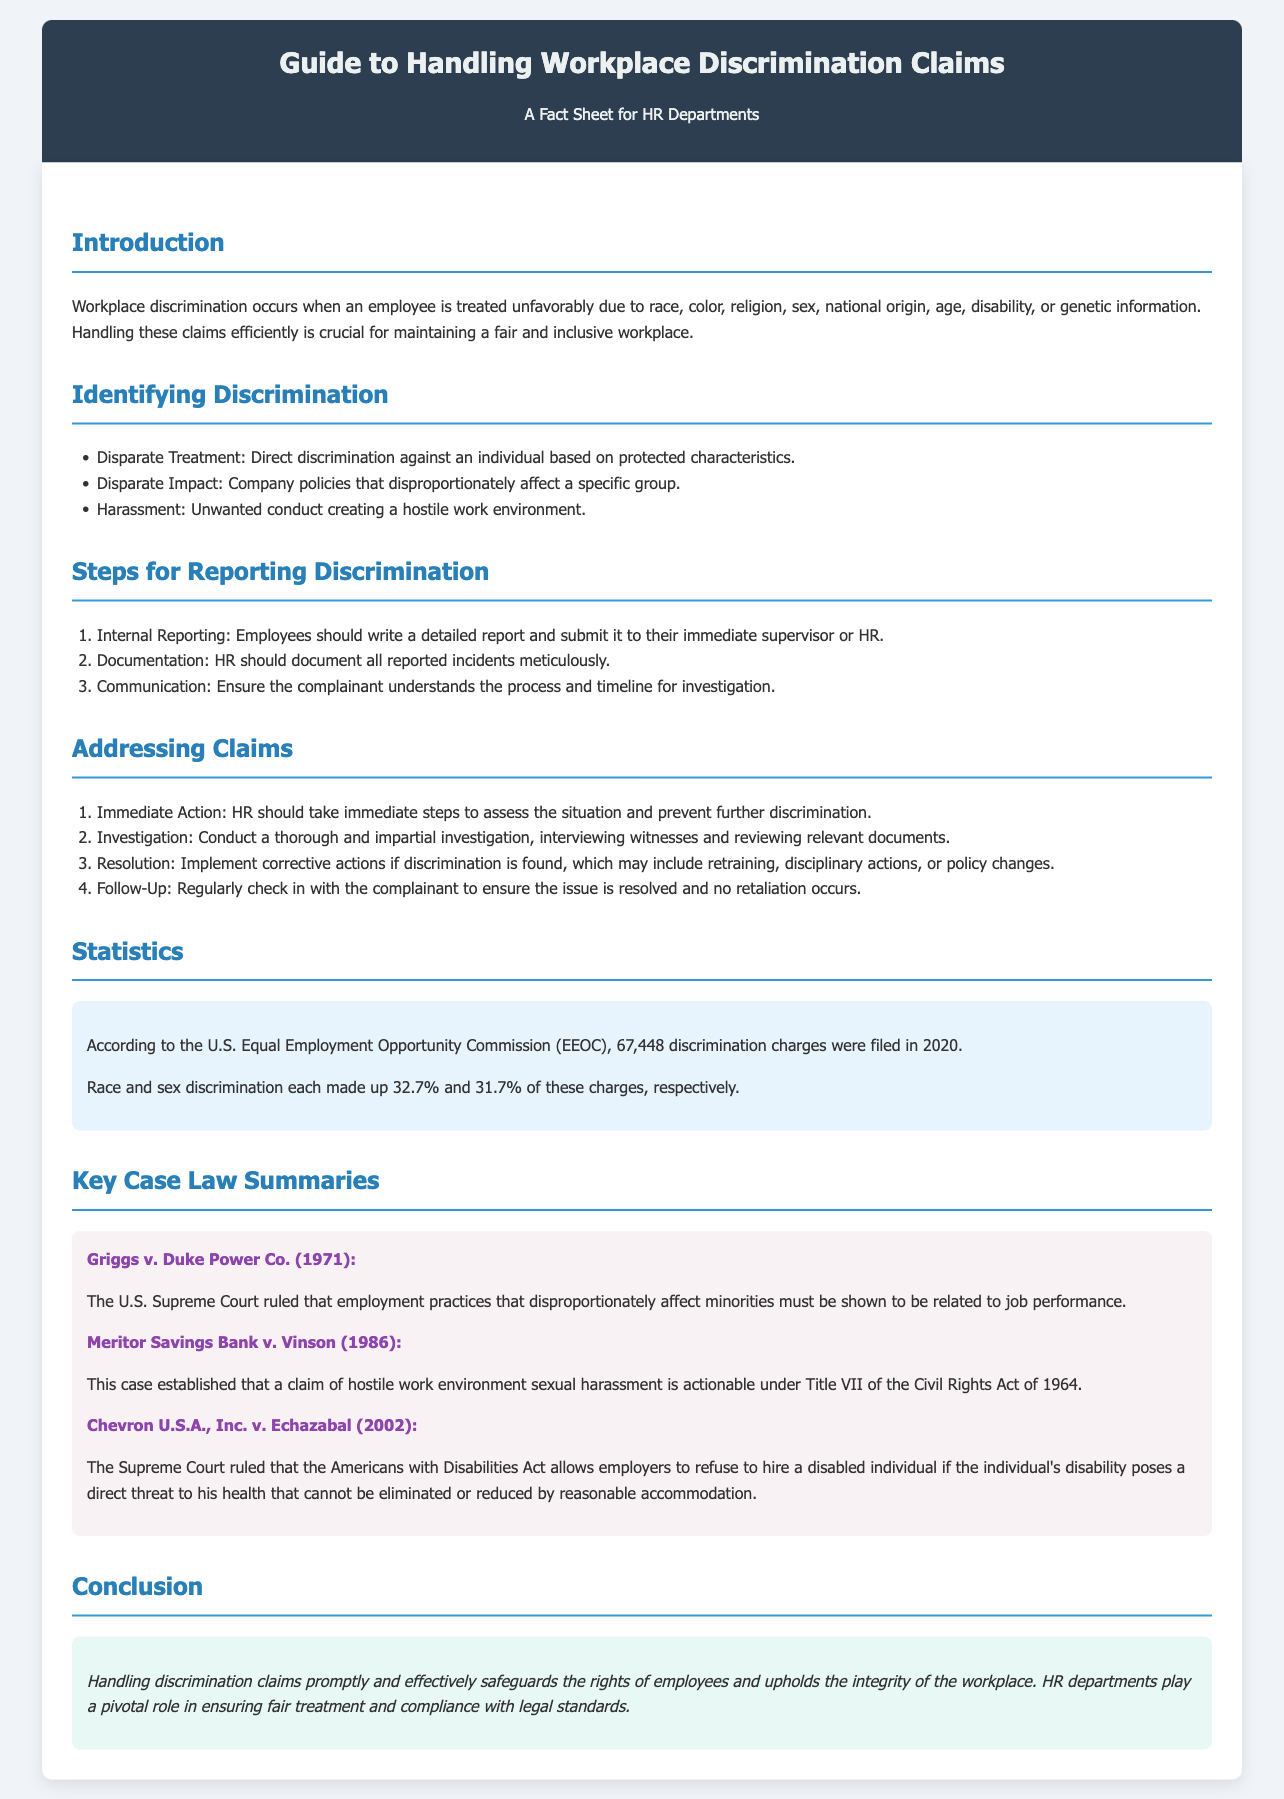What is the total number of discrimination charges filed in 2020? The total number of discrimination charges is stated in the document, which is 67,448.
Answer: 67,448 What percentage of charges were based on race discrimination? The document specifies that race discrimination made up 32.7% of the charges filed.
Answer: 32.7% What is the first step for reporting discrimination? The first step outlined in the document is "Internal Reporting," where employees write a report to their supervisor or HR.
Answer: Internal Reporting Which case established that a claim of hostile work environment sexual harassment is actionable? The document mentions "Meritor Savings Bank v. Vinson (1986)" as the case that established this claim under Title VII.
Answer: Meritor Savings Bank v. Vinson What is meant by "Disparate Impact"? The document defines "Disparate Impact" as company policies that disproportionately affect a specific group.
Answer: Company policies affecting a specific group What immediate action should HR take when a discrimination claim is reported? The document states that HR should take immediate steps to assess the situation and prevent further discrimination.
Answer: Assess the situation What is the purpose of addressing discrimination claims promptly? The document explains that prompt handling safeguards employee rights and upholds workplace integrity.
Answer: Safeguards employee rights How many key case law summaries are provided in the document? The document includes three key case law summaries related to discrimination cases.
Answer: Three What type of environment does harassment create? The document describes harassment as creating a hostile work environment.
Answer: Hostile work environment 